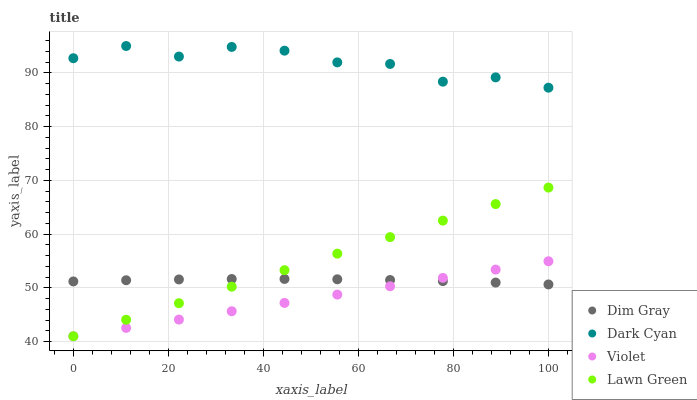Does Violet have the minimum area under the curve?
Answer yes or no. Yes. Does Dark Cyan have the maximum area under the curve?
Answer yes or no. Yes. Does Lawn Green have the minimum area under the curve?
Answer yes or no. No. Does Lawn Green have the maximum area under the curve?
Answer yes or no. No. Is Violet the smoothest?
Answer yes or no. Yes. Is Dark Cyan the roughest?
Answer yes or no. Yes. Is Lawn Green the smoothest?
Answer yes or no. No. Is Lawn Green the roughest?
Answer yes or no. No. Does Lawn Green have the lowest value?
Answer yes or no. Yes. Does Dim Gray have the lowest value?
Answer yes or no. No. Does Dark Cyan have the highest value?
Answer yes or no. Yes. Does Lawn Green have the highest value?
Answer yes or no. No. Is Violet less than Dark Cyan?
Answer yes or no. Yes. Is Dark Cyan greater than Lawn Green?
Answer yes or no. Yes. Does Violet intersect Lawn Green?
Answer yes or no. Yes. Is Violet less than Lawn Green?
Answer yes or no. No. Is Violet greater than Lawn Green?
Answer yes or no. No. Does Violet intersect Dark Cyan?
Answer yes or no. No. 